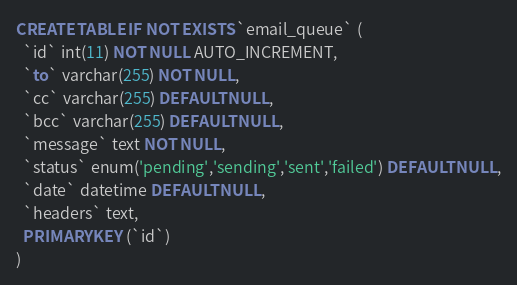Convert code to text. <code><loc_0><loc_0><loc_500><loc_500><_SQL_>CREATE TABLE IF NOT EXISTS `email_queue` (
  `id` int(11) NOT NULL AUTO_INCREMENT,
  `to` varchar(255) NOT NULL,
  `cc` varchar(255) DEFAULT NULL,
  `bcc` varchar(255) DEFAULT NULL,
  `message` text NOT NULL,
  `status` enum('pending','sending','sent','failed') DEFAULT NULL,
  `date` datetime DEFAULT NULL,
  `headers` text,
  PRIMARY KEY (`id`)
)</code> 